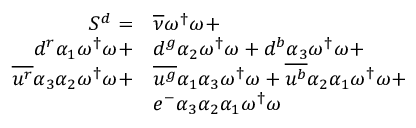Convert formula to latex. <formula><loc_0><loc_0><loc_500><loc_500>\begin{array} { r l } { S ^ { d } = } & { { \overline { \nu } } \omega ^ { \dagger } \omega + } \\ { { d } ^ { r } { \alpha _ { 1 } } \omega ^ { \dagger } \omega + } & { { d } ^ { g } { \alpha _ { 2 } } \omega ^ { \dagger } \omega + { d } ^ { b } { \alpha _ { 3 } } \omega ^ { \dagger } \omega + } \\ { \overline { { u ^ { r } } } { \alpha _ { 3 } } { \alpha _ { 2 } } \omega ^ { \dagger } \omega + } & { \overline { { u ^ { g } } } { \alpha _ { 1 } } { \alpha _ { 3 } } \omega ^ { \dagger } \omega + \overline { { u ^ { b } } } { \alpha _ { 2 } } { \alpha _ { 1 } } \omega ^ { \dagger } \omega + } \\ & { e ^ { - } { \alpha _ { 3 } } { \alpha _ { 2 } } { \alpha _ { 1 } } \omega ^ { \dagger } \omega } \end{array}</formula> 